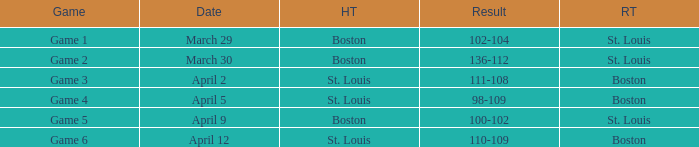On what Date is Game 3 with Boston Road Team? April 2. 